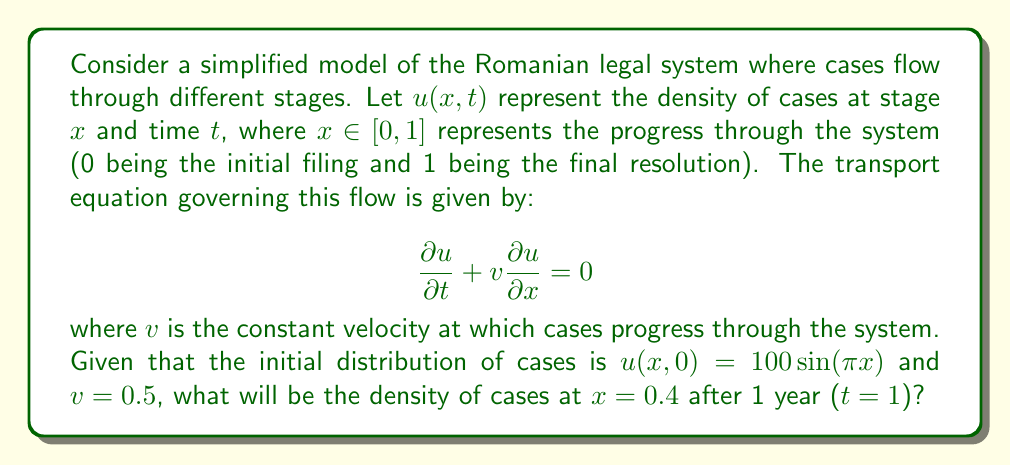Can you solve this math problem? To solve this problem, we need to use the method of characteristics for the transport equation. The steps are as follows:

1) The general solution to the transport equation is given by:
   
   $u(x,t) = f(x - vt)$

   where $f$ is determined by the initial condition.

2) From the initial condition, we have:
   
   $u(x,0) = 100\sin(\pi x) = f(x)$

3) Therefore, the solution is:
   
   $u(x,t) = 100\sin(\pi(x - vt))$

4) We're asked to find $u(0.4, 1)$ with $v = 0.5$. Let's substitute these values:

   $u(0.4, 1) = 100\sin(\pi(0.4 - 0.5 \cdot 1))$
               $= 100\sin(\pi(-0.1))$
               $= 100\sin(-0.1\pi)$
               $= -100\sin(0.1\pi)$

5) Using a calculator or approximation, we can evaluate this:

   $u(0.4, 1) \approx -31.29$

The negative sign indicates that the flow of cases has reversed direction at this point and time, which may not be physically meaningful in the context of the legal system. In practice, we might interpret this as the absolute value.
Answer: The density of cases at $x = 0.4$ after 1 year is approximately 31.29 cases per unit length. 